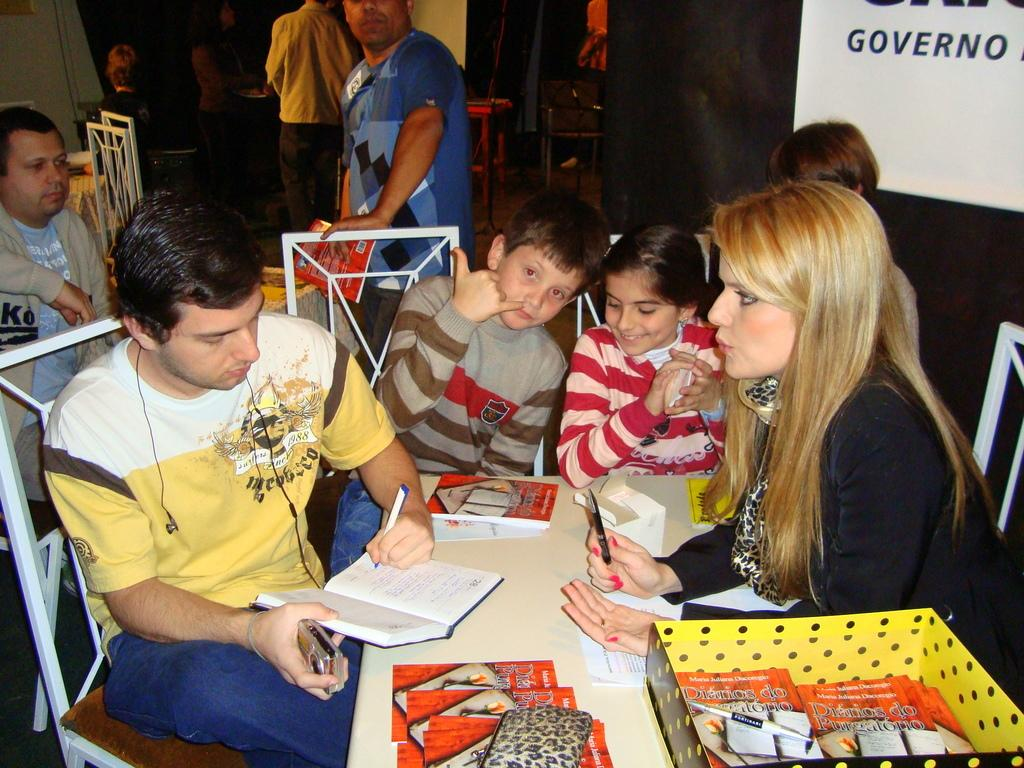<image>
Summarize the visual content of the image. The person signing books is called Maria Juliana Dacorego 